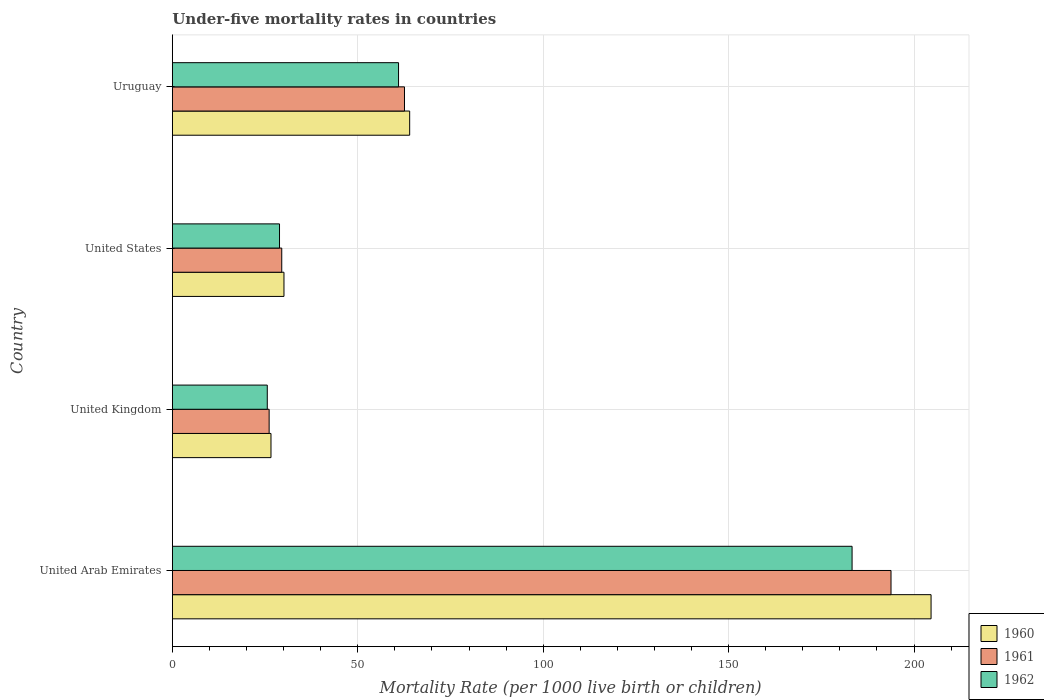How many different coloured bars are there?
Make the answer very short. 3. Are the number of bars per tick equal to the number of legend labels?
Provide a short and direct response. Yes. Are the number of bars on each tick of the Y-axis equal?
Offer a very short reply. Yes. How many bars are there on the 3rd tick from the top?
Your response must be concise. 3. How many bars are there on the 4th tick from the bottom?
Provide a short and direct response. 3. What is the label of the 4th group of bars from the top?
Provide a succinct answer. United Arab Emirates. In how many cases, is the number of bars for a given country not equal to the number of legend labels?
Provide a short and direct response. 0. What is the under-five mortality rate in 1960 in United Arab Emirates?
Make the answer very short. 204.6. Across all countries, what is the maximum under-five mortality rate in 1961?
Provide a short and direct response. 193.8. Across all countries, what is the minimum under-five mortality rate in 1962?
Provide a short and direct response. 25.6. In which country was the under-five mortality rate in 1962 maximum?
Ensure brevity in your answer.  United Arab Emirates. What is the total under-five mortality rate in 1962 in the graph?
Ensure brevity in your answer.  298.8. What is the difference between the under-five mortality rate in 1961 in United Kingdom and that in Uruguay?
Ensure brevity in your answer.  -36.5. What is the difference between the under-five mortality rate in 1960 in United Kingdom and the under-five mortality rate in 1961 in Uruguay?
Keep it short and to the point. -36. What is the difference between the under-five mortality rate in 1962 and under-five mortality rate in 1960 in United Arab Emirates?
Your answer should be very brief. -21.3. In how many countries, is the under-five mortality rate in 1962 greater than 70 ?
Your answer should be compact. 1. What is the ratio of the under-five mortality rate in 1962 in United Kingdom to that in Uruguay?
Keep it short and to the point. 0.42. Is the under-five mortality rate in 1962 in United Kingdom less than that in Uruguay?
Your response must be concise. Yes. What is the difference between the highest and the second highest under-five mortality rate in 1962?
Offer a terse response. 122.3. What is the difference between the highest and the lowest under-five mortality rate in 1961?
Give a very brief answer. 167.7. In how many countries, is the under-five mortality rate in 1961 greater than the average under-five mortality rate in 1961 taken over all countries?
Your response must be concise. 1. What does the 1st bar from the top in United States represents?
Give a very brief answer. 1962. What does the 3rd bar from the bottom in Uruguay represents?
Your answer should be very brief. 1962. Are all the bars in the graph horizontal?
Make the answer very short. Yes. How many countries are there in the graph?
Keep it short and to the point. 4. What is the difference between two consecutive major ticks on the X-axis?
Your response must be concise. 50. Are the values on the major ticks of X-axis written in scientific E-notation?
Keep it short and to the point. No. Does the graph contain grids?
Provide a succinct answer. Yes. How many legend labels are there?
Make the answer very short. 3. What is the title of the graph?
Your answer should be very brief. Under-five mortality rates in countries. Does "1971" appear as one of the legend labels in the graph?
Make the answer very short. No. What is the label or title of the X-axis?
Give a very brief answer. Mortality Rate (per 1000 live birth or children). What is the label or title of the Y-axis?
Offer a terse response. Country. What is the Mortality Rate (per 1000 live birth or children) of 1960 in United Arab Emirates?
Your response must be concise. 204.6. What is the Mortality Rate (per 1000 live birth or children) in 1961 in United Arab Emirates?
Ensure brevity in your answer.  193.8. What is the Mortality Rate (per 1000 live birth or children) in 1962 in United Arab Emirates?
Give a very brief answer. 183.3. What is the Mortality Rate (per 1000 live birth or children) of 1960 in United Kingdom?
Your response must be concise. 26.6. What is the Mortality Rate (per 1000 live birth or children) in 1961 in United Kingdom?
Offer a very short reply. 26.1. What is the Mortality Rate (per 1000 live birth or children) in 1962 in United Kingdom?
Your response must be concise. 25.6. What is the Mortality Rate (per 1000 live birth or children) in 1960 in United States?
Keep it short and to the point. 30.1. What is the Mortality Rate (per 1000 live birth or children) of 1961 in United States?
Offer a terse response. 29.5. What is the Mortality Rate (per 1000 live birth or children) of 1962 in United States?
Offer a terse response. 28.9. What is the Mortality Rate (per 1000 live birth or children) in 1961 in Uruguay?
Make the answer very short. 62.6. What is the Mortality Rate (per 1000 live birth or children) in 1962 in Uruguay?
Provide a succinct answer. 61. Across all countries, what is the maximum Mortality Rate (per 1000 live birth or children) of 1960?
Your response must be concise. 204.6. Across all countries, what is the maximum Mortality Rate (per 1000 live birth or children) of 1961?
Your answer should be compact. 193.8. Across all countries, what is the maximum Mortality Rate (per 1000 live birth or children) of 1962?
Your answer should be very brief. 183.3. Across all countries, what is the minimum Mortality Rate (per 1000 live birth or children) of 1960?
Your answer should be very brief. 26.6. Across all countries, what is the minimum Mortality Rate (per 1000 live birth or children) in 1961?
Ensure brevity in your answer.  26.1. Across all countries, what is the minimum Mortality Rate (per 1000 live birth or children) in 1962?
Offer a terse response. 25.6. What is the total Mortality Rate (per 1000 live birth or children) in 1960 in the graph?
Keep it short and to the point. 325.3. What is the total Mortality Rate (per 1000 live birth or children) of 1961 in the graph?
Ensure brevity in your answer.  312. What is the total Mortality Rate (per 1000 live birth or children) in 1962 in the graph?
Provide a succinct answer. 298.8. What is the difference between the Mortality Rate (per 1000 live birth or children) of 1960 in United Arab Emirates and that in United Kingdom?
Your answer should be very brief. 178. What is the difference between the Mortality Rate (per 1000 live birth or children) of 1961 in United Arab Emirates and that in United Kingdom?
Ensure brevity in your answer.  167.7. What is the difference between the Mortality Rate (per 1000 live birth or children) of 1962 in United Arab Emirates and that in United Kingdom?
Offer a very short reply. 157.7. What is the difference between the Mortality Rate (per 1000 live birth or children) of 1960 in United Arab Emirates and that in United States?
Your response must be concise. 174.5. What is the difference between the Mortality Rate (per 1000 live birth or children) of 1961 in United Arab Emirates and that in United States?
Your response must be concise. 164.3. What is the difference between the Mortality Rate (per 1000 live birth or children) in 1962 in United Arab Emirates and that in United States?
Make the answer very short. 154.4. What is the difference between the Mortality Rate (per 1000 live birth or children) of 1960 in United Arab Emirates and that in Uruguay?
Offer a terse response. 140.6. What is the difference between the Mortality Rate (per 1000 live birth or children) of 1961 in United Arab Emirates and that in Uruguay?
Your response must be concise. 131.2. What is the difference between the Mortality Rate (per 1000 live birth or children) of 1962 in United Arab Emirates and that in Uruguay?
Provide a succinct answer. 122.3. What is the difference between the Mortality Rate (per 1000 live birth or children) of 1960 in United Kingdom and that in United States?
Offer a very short reply. -3.5. What is the difference between the Mortality Rate (per 1000 live birth or children) in 1960 in United Kingdom and that in Uruguay?
Offer a very short reply. -37.4. What is the difference between the Mortality Rate (per 1000 live birth or children) of 1961 in United Kingdom and that in Uruguay?
Offer a very short reply. -36.5. What is the difference between the Mortality Rate (per 1000 live birth or children) in 1962 in United Kingdom and that in Uruguay?
Provide a succinct answer. -35.4. What is the difference between the Mortality Rate (per 1000 live birth or children) of 1960 in United States and that in Uruguay?
Offer a terse response. -33.9. What is the difference between the Mortality Rate (per 1000 live birth or children) in 1961 in United States and that in Uruguay?
Make the answer very short. -33.1. What is the difference between the Mortality Rate (per 1000 live birth or children) of 1962 in United States and that in Uruguay?
Make the answer very short. -32.1. What is the difference between the Mortality Rate (per 1000 live birth or children) of 1960 in United Arab Emirates and the Mortality Rate (per 1000 live birth or children) of 1961 in United Kingdom?
Offer a terse response. 178.5. What is the difference between the Mortality Rate (per 1000 live birth or children) of 1960 in United Arab Emirates and the Mortality Rate (per 1000 live birth or children) of 1962 in United Kingdom?
Give a very brief answer. 179. What is the difference between the Mortality Rate (per 1000 live birth or children) in 1961 in United Arab Emirates and the Mortality Rate (per 1000 live birth or children) in 1962 in United Kingdom?
Your response must be concise. 168.2. What is the difference between the Mortality Rate (per 1000 live birth or children) of 1960 in United Arab Emirates and the Mortality Rate (per 1000 live birth or children) of 1961 in United States?
Make the answer very short. 175.1. What is the difference between the Mortality Rate (per 1000 live birth or children) in 1960 in United Arab Emirates and the Mortality Rate (per 1000 live birth or children) in 1962 in United States?
Provide a succinct answer. 175.7. What is the difference between the Mortality Rate (per 1000 live birth or children) of 1961 in United Arab Emirates and the Mortality Rate (per 1000 live birth or children) of 1962 in United States?
Make the answer very short. 164.9. What is the difference between the Mortality Rate (per 1000 live birth or children) of 1960 in United Arab Emirates and the Mortality Rate (per 1000 live birth or children) of 1961 in Uruguay?
Make the answer very short. 142. What is the difference between the Mortality Rate (per 1000 live birth or children) in 1960 in United Arab Emirates and the Mortality Rate (per 1000 live birth or children) in 1962 in Uruguay?
Your response must be concise. 143.6. What is the difference between the Mortality Rate (per 1000 live birth or children) of 1961 in United Arab Emirates and the Mortality Rate (per 1000 live birth or children) of 1962 in Uruguay?
Provide a short and direct response. 132.8. What is the difference between the Mortality Rate (per 1000 live birth or children) in 1960 in United Kingdom and the Mortality Rate (per 1000 live birth or children) in 1961 in Uruguay?
Your response must be concise. -36. What is the difference between the Mortality Rate (per 1000 live birth or children) of 1960 in United Kingdom and the Mortality Rate (per 1000 live birth or children) of 1962 in Uruguay?
Ensure brevity in your answer.  -34.4. What is the difference between the Mortality Rate (per 1000 live birth or children) of 1961 in United Kingdom and the Mortality Rate (per 1000 live birth or children) of 1962 in Uruguay?
Provide a succinct answer. -34.9. What is the difference between the Mortality Rate (per 1000 live birth or children) of 1960 in United States and the Mortality Rate (per 1000 live birth or children) of 1961 in Uruguay?
Your answer should be very brief. -32.5. What is the difference between the Mortality Rate (per 1000 live birth or children) of 1960 in United States and the Mortality Rate (per 1000 live birth or children) of 1962 in Uruguay?
Your answer should be compact. -30.9. What is the difference between the Mortality Rate (per 1000 live birth or children) in 1961 in United States and the Mortality Rate (per 1000 live birth or children) in 1962 in Uruguay?
Keep it short and to the point. -31.5. What is the average Mortality Rate (per 1000 live birth or children) of 1960 per country?
Ensure brevity in your answer.  81.33. What is the average Mortality Rate (per 1000 live birth or children) of 1961 per country?
Offer a terse response. 78. What is the average Mortality Rate (per 1000 live birth or children) in 1962 per country?
Your answer should be very brief. 74.7. What is the difference between the Mortality Rate (per 1000 live birth or children) of 1960 and Mortality Rate (per 1000 live birth or children) of 1961 in United Arab Emirates?
Make the answer very short. 10.8. What is the difference between the Mortality Rate (per 1000 live birth or children) in 1960 and Mortality Rate (per 1000 live birth or children) in 1962 in United Arab Emirates?
Keep it short and to the point. 21.3. What is the difference between the Mortality Rate (per 1000 live birth or children) of 1960 and Mortality Rate (per 1000 live birth or children) of 1961 in United Kingdom?
Offer a very short reply. 0.5. What is the difference between the Mortality Rate (per 1000 live birth or children) of 1960 and Mortality Rate (per 1000 live birth or children) of 1961 in United States?
Give a very brief answer. 0.6. What is the difference between the Mortality Rate (per 1000 live birth or children) in 1960 and Mortality Rate (per 1000 live birth or children) in 1962 in United States?
Offer a terse response. 1.2. What is the difference between the Mortality Rate (per 1000 live birth or children) of 1961 and Mortality Rate (per 1000 live birth or children) of 1962 in United States?
Your answer should be very brief. 0.6. What is the difference between the Mortality Rate (per 1000 live birth or children) in 1960 and Mortality Rate (per 1000 live birth or children) in 1961 in Uruguay?
Keep it short and to the point. 1.4. What is the ratio of the Mortality Rate (per 1000 live birth or children) of 1960 in United Arab Emirates to that in United Kingdom?
Provide a succinct answer. 7.69. What is the ratio of the Mortality Rate (per 1000 live birth or children) in 1961 in United Arab Emirates to that in United Kingdom?
Keep it short and to the point. 7.43. What is the ratio of the Mortality Rate (per 1000 live birth or children) in 1962 in United Arab Emirates to that in United Kingdom?
Give a very brief answer. 7.16. What is the ratio of the Mortality Rate (per 1000 live birth or children) of 1960 in United Arab Emirates to that in United States?
Keep it short and to the point. 6.8. What is the ratio of the Mortality Rate (per 1000 live birth or children) in 1961 in United Arab Emirates to that in United States?
Your answer should be compact. 6.57. What is the ratio of the Mortality Rate (per 1000 live birth or children) of 1962 in United Arab Emirates to that in United States?
Provide a succinct answer. 6.34. What is the ratio of the Mortality Rate (per 1000 live birth or children) in 1960 in United Arab Emirates to that in Uruguay?
Ensure brevity in your answer.  3.2. What is the ratio of the Mortality Rate (per 1000 live birth or children) of 1961 in United Arab Emirates to that in Uruguay?
Make the answer very short. 3.1. What is the ratio of the Mortality Rate (per 1000 live birth or children) in 1962 in United Arab Emirates to that in Uruguay?
Offer a very short reply. 3. What is the ratio of the Mortality Rate (per 1000 live birth or children) in 1960 in United Kingdom to that in United States?
Make the answer very short. 0.88. What is the ratio of the Mortality Rate (per 1000 live birth or children) of 1961 in United Kingdom to that in United States?
Offer a terse response. 0.88. What is the ratio of the Mortality Rate (per 1000 live birth or children) in 1962 in United Kingdom to that in United States?
Ensure brevity in your answer.  0.89. What is the ratio of the Mortality Rate (per 1000 live birth or children) of 1960 in United Kingdom to that in Uruguay?
Make the answer very short. 0.42. What is the ratio of the Mortality Rate (per 1000 live birth or children) of 1961 in United Kingdom to that in Uruguay?
Provide a succinct answer. 0.42. What is the ratio of the Mortality Rate (per 1000 live birth or children) of 1962 in United Kingdom to that in Uruguay?
Give a very brief answer. 0.42. What is the ratio of the Mortality Rate (per 1000 live birth or children) of 1960 in United States to that in Uruguay?
Ensure brevity in your answer.  0.47. What is the ratio of the Mortality Rate (per 1000 live birth or children) of 1961 in United States to that in Uruguay?
Your answer should be compact. 0.47. What is the ratio of the Mortality Rate (per 1000 live birth or children) of 1962 in United States to that in Uruguay?
Your answer should be very brief. 0.47. What is the difference between the highest and the second highest Mortality Rate (per 1000 live birth or children) of 1960?
Make the answer very short. 140.6. What is the difference between the highest and the second highest Mortality Rate (per 1000 live birth or children) of 1961?
Your response must be concise. 131.2. What is the difference between the highest and the second highest Mortality Rate (per 1000 live birth or children) of 1962?
Keep it short and to the point. 122.3. What is the difference between the highest and the lowest Mortality Rate (per 1000 live birth or children) of 1960?
Ensure brevity in your answer.  178. What is the difference between the highest and the lowest Mortality Rate (per 1000 live birth or children) of 1961?
Give a very brief answer. 167.7. What is the difference between the highest and the lowest Mortality Rate (per 1000 live birth or children) of 1962?
Make the answer very short. 157.7. 